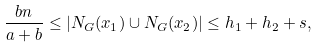<formula> <loc_0><loc_0><loc_500><loc_500>\frac { b n } { a + b } \leq | N _ { G } ( x _ { 1 } ) \cup N _ { G } ( x _ { 2 } ) | \leq h _ { 1 } + h _ { 2 } + s ,</formula> 